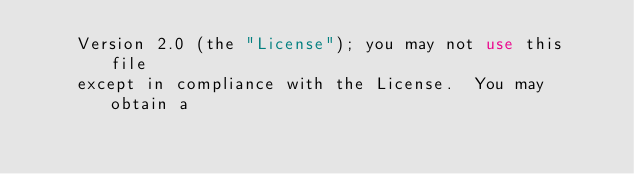<code> <loc_0><loc_0><loc_500><loc_500><_XML_>    Version 2.0 (the "License"); you may not use this file
    except in compliance with the License.  You may obtain a</code> 